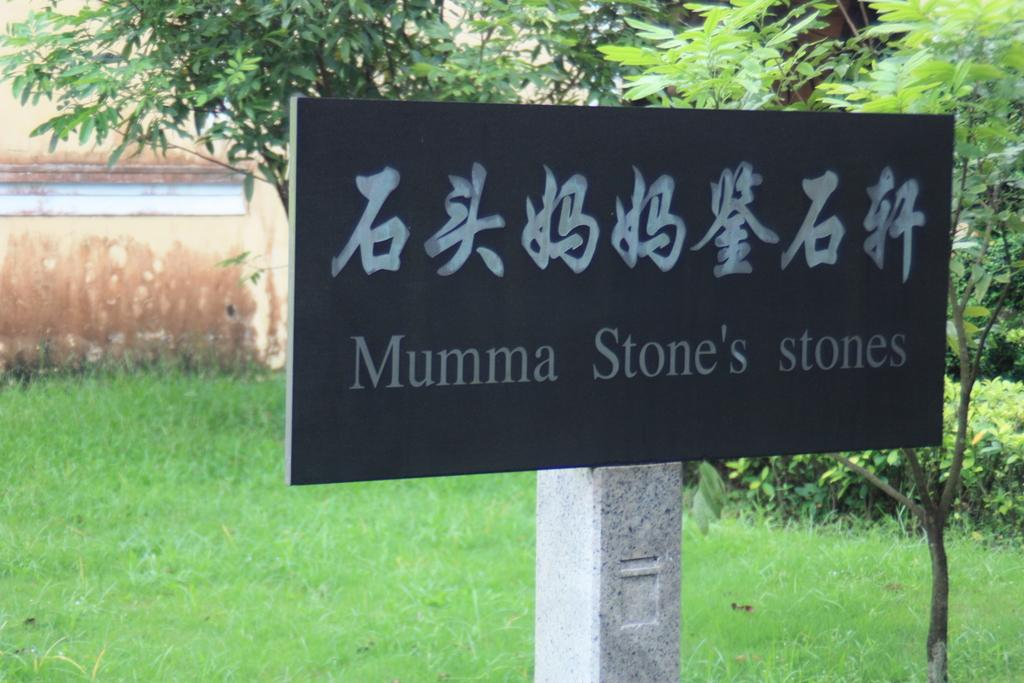What is the main object in the image? There is a blackboard in the image. What can be seen on the blackboard? The blackboard has something written on it. How is the blackboard supported or attached? The blackboard is attached to a pole. What type of natural elements can be seen in the image? There are trees in the right corner of the image, and the ground appears to be covered in greenery. What type of magic is being performed on the blackboard in the image? There is no indication of magic being performed in the image; it simply shows a blackboard with something written on it. What shape is the car in the image? There is no car present in the image. 